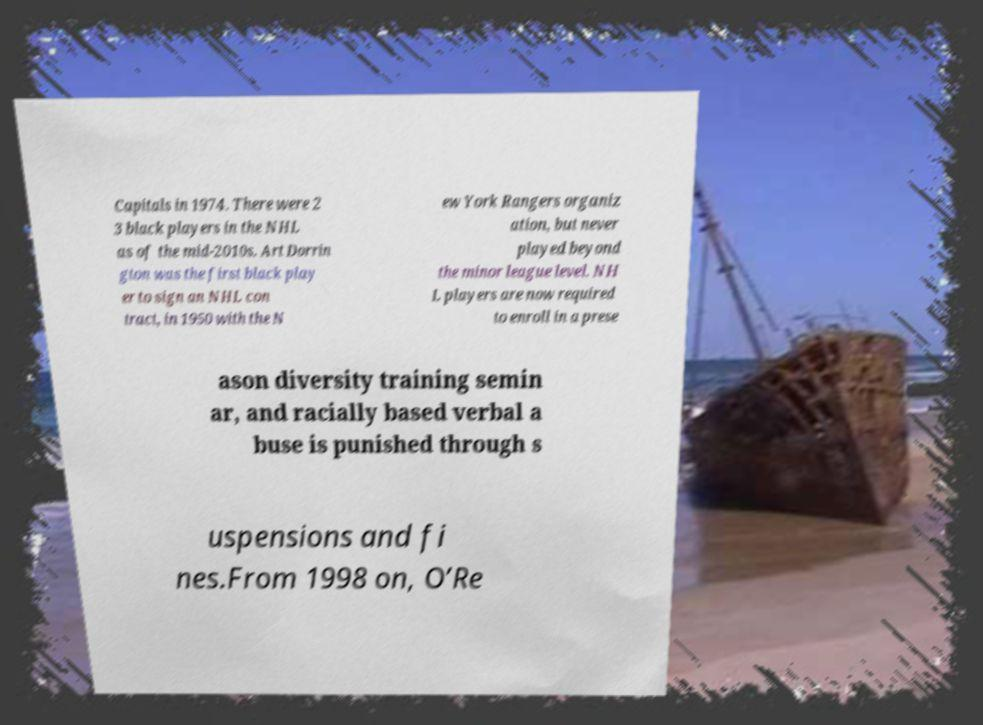I need the written content from this picture converted into text. Can you do that? Capitals in 1974. There were 2 3 black players in the NHL as of the mid-2010s. Art Dorrin gton was the first black play er to sign an NHL con tract, in 1950 with the N ew York Rangers organiz ation, but never played beyond the minor league level. NH L players are now required to enroll in a prese ason diversity training semin ar, and racially based verbal a buse is punished through s uspensions and fi nes.From 1998 on, O’Re 